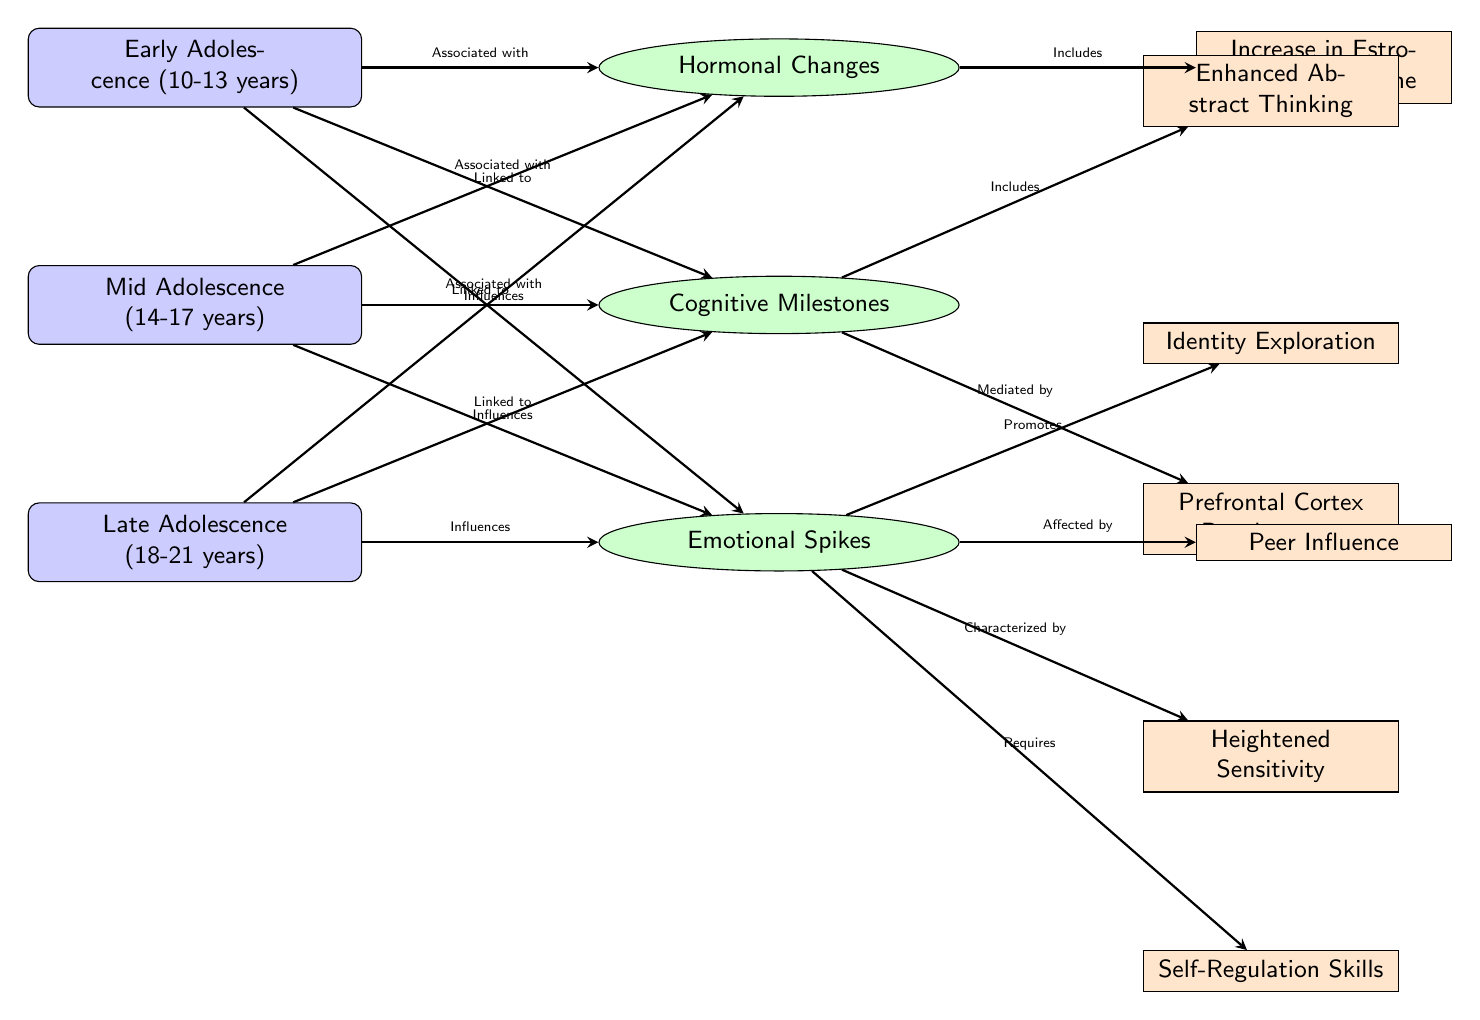What are the three stages of adolescence depicted in the diagram? The diagram displays three stages of adolescence labeled: Early Adolescence (10-13 years), Mid Adolescence (14-17 years), and Late Adolescence (18-21 years). These stages are clearly named in separate nodes on the left side of the diagram.
Answer: Early Adolescence, Mid Adolescence, Late Adolescence Which aspect is included under "Hormonal Changes"? The aspect listed under "Hormonal Changes" is "Increase in Estrogen/Testosterone". This is derived from the connection that shows the direct relationship from "Hormonal Changes" to this specific aspect node.
Answer: Increase in Estrogen/Testosterone How many aspects are related to "Emotional Spikes"? There are four aspects that relate to "Emotional Spikes": "Identity Exploration", "Peer Influence", "Heightened Sensitivity", and "Self-Regulation Skills". This count can be determined by counting the aspect nodes that connect to "Emotional Spikes".
Answer: 4 What type of thinking is enhanced during Mid Adolescence? The diagram indicates that "Enhanced Abstract Thinking" is included under the "Cognitive Milestones" for Mid Adolescence. This aspect is directly linked to the cognitive node associated with this stage.
Answer: Enhanced Abstract Thinking How does "Prefrontal Cortex Development" relate to cognitive milestones? "Prefrontal Cortex Development" is indicated as being mediated by "Cognitive Milestones". This connection highlights how this specific aspect influences or interacts with cognitive milestones in adolescents.
Answer: Mediated by What influences does the diagram suggest in early adolescence? The diagram illustrates that in early adolescence, hormonal changes, cognitive milestones, and emotional spikes all influence development. Each connection shows that these factors are directly associated with the early stage of adolescence.
Answer: Hormonal Changes, Cognitive Milestones, Emotional Spikes 